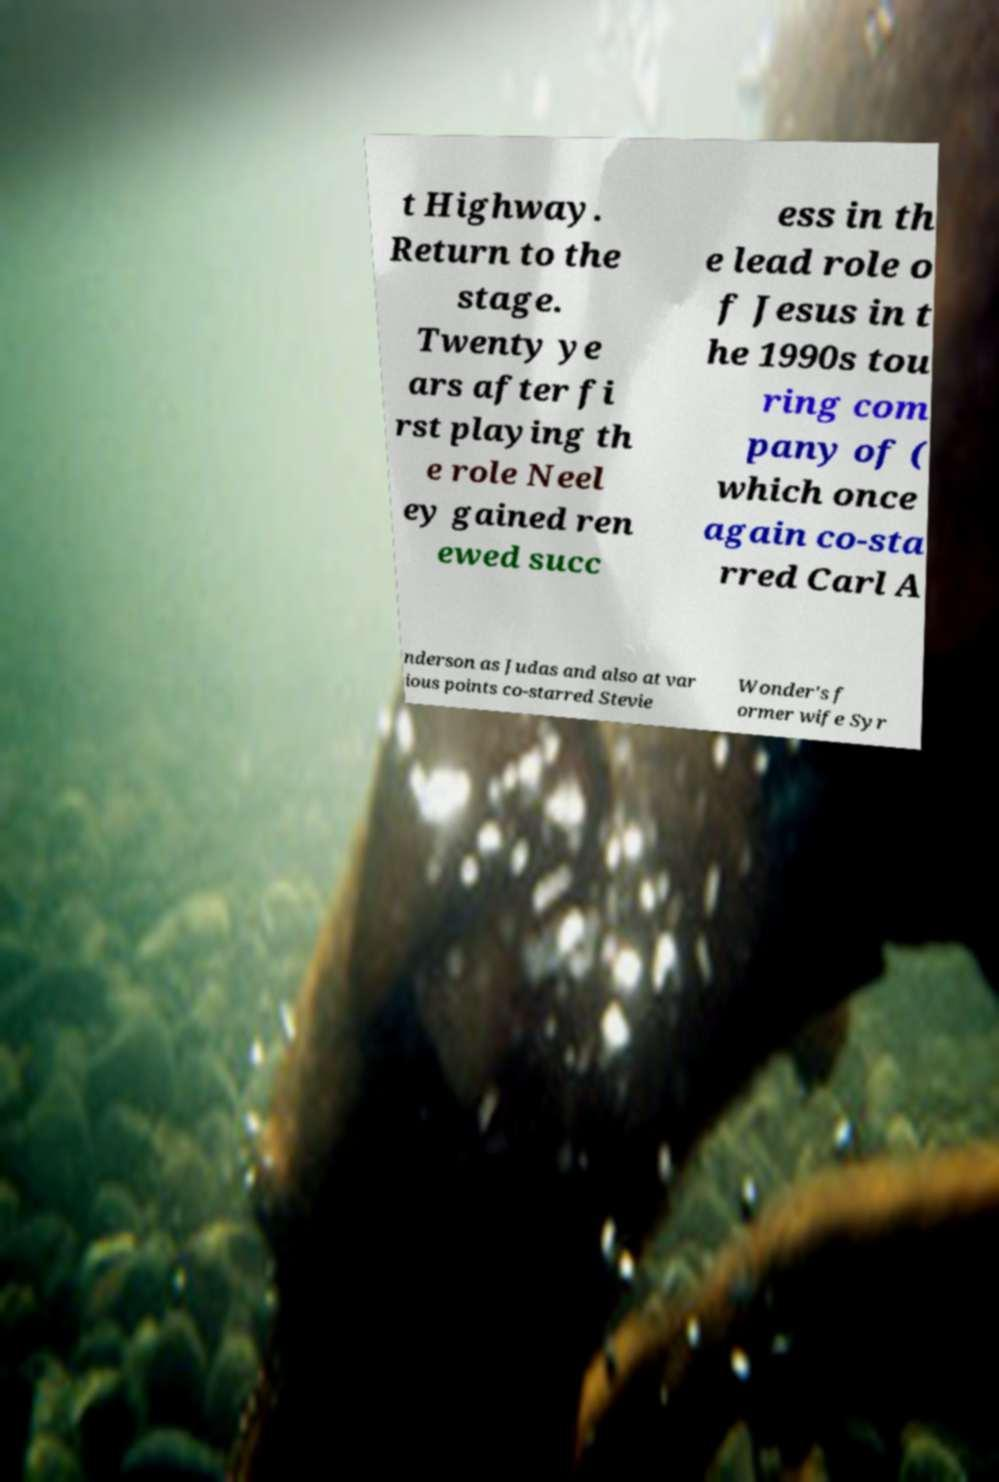For documentation purposes, I need the text within this image transcribed. Could you provide that? t Highway. Return to the stage. Twenty ye ars after fi rst playing th e role Neel ey gained ren ewed succ ess in th e lead role o f Jesus in t he 1990s tou ring com pany of ( which once again co-sta rred Carl A nderson as Judas and also at var ious points co-starred Stevie Wonder's f ormer wife Syr 